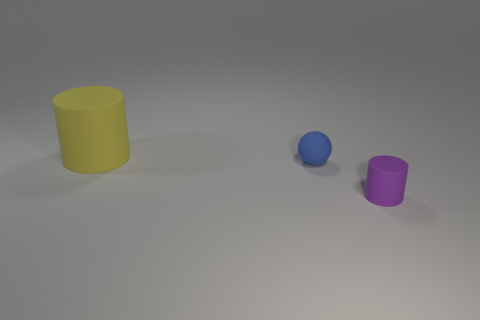How many objects are small purple cylinders or large yellow cylinders?
Offer a very short reply. 2. There is a rubber thing right of the tiny rubber sphere; does it have the same color as the matte cylinder behind the small purple matte thing?
Your answer should be very brief. No. The blue matte object that is the same size as the purple thing is what shape?
Provide a succinct answer. Sphere. What number of things are things in front of the big object or matte things that are in front of the blue ball?
Ensure brevity in your answer.  2. Are there fewer tiny blue objects than cylinders?
Offer a terse response. Yes. There is a blue thing that is the same size as the purple thing; what is its material?
Your answer should be compact. Rubber. There is a cylinder that is in front of the large cylinder; is its size the same as the blue sphere to the left of the tiny matte cylinder?
Ensure brevity in your answer.  Yes. Is there a large yellow cylinder made of the same material as the tiny purple cylinder?
Provide a succinct answer. Yes. How many things are either things in front of the big cylinder or big yellow things?
Offer a terse response. 3. Is the large yellow matte object the same shape as the small purple rubber object?
Provide a succinct answer. Yes. 